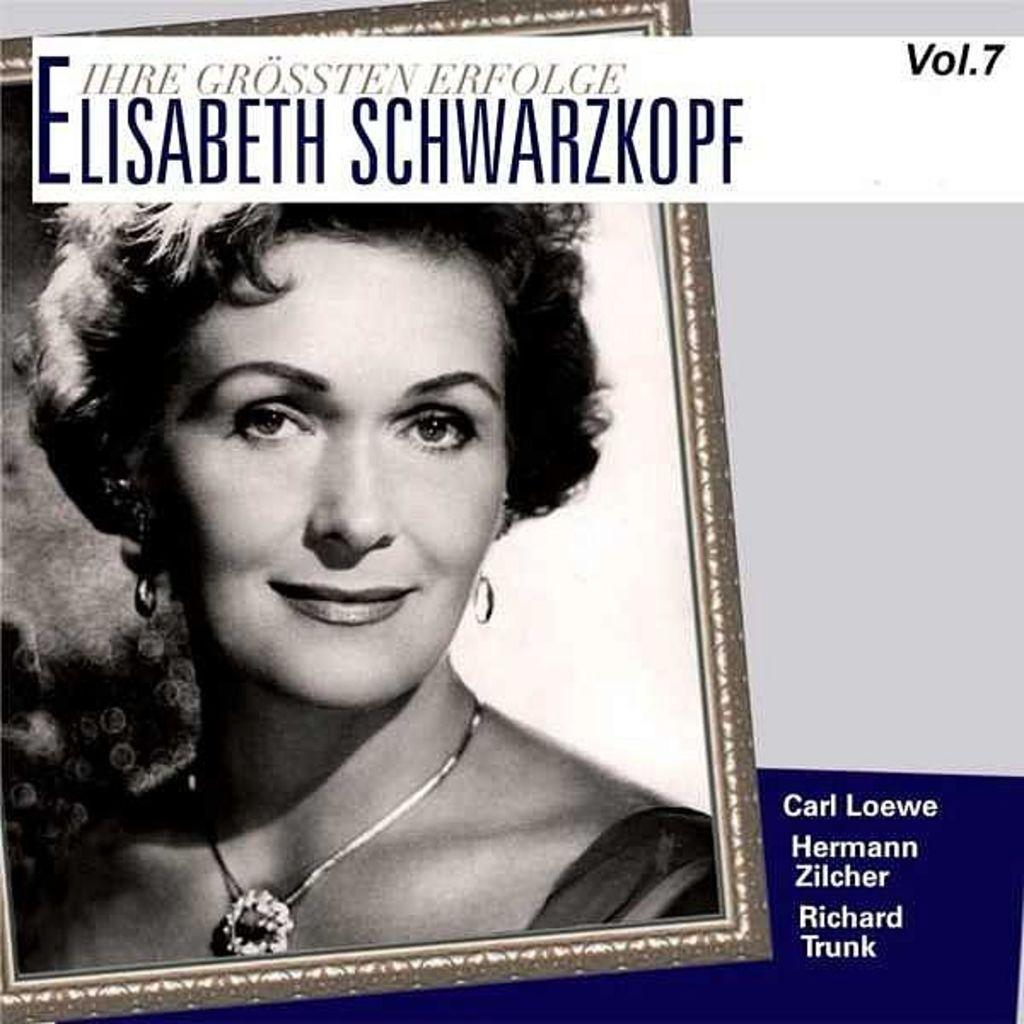What object is present in the image that typically holds a picture? There is a photo frame in the image. What can be seen inside the photo frame? The photo frame contains a picture of a person. What else is visible on the right side of the image? There is text on the right side of the image. What type of bread is being used to create the wax sculpture in the image? There is no bread or wax sculpture present in the image. How does the current affect the person in the photo frame? The image does not depict any current or electrical activity, so it cannot be determined how it would affect the person in the photo frame. 